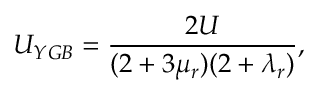Convert formula to latex. <formula><loc_0><loc_0><loc_500><loc_500>U _ { Y G B } = \frac { 2 U } { ( 2 + 3 \mu _ { r } ) ( 2 + \lambda _ { r } ) } ,</formula> 